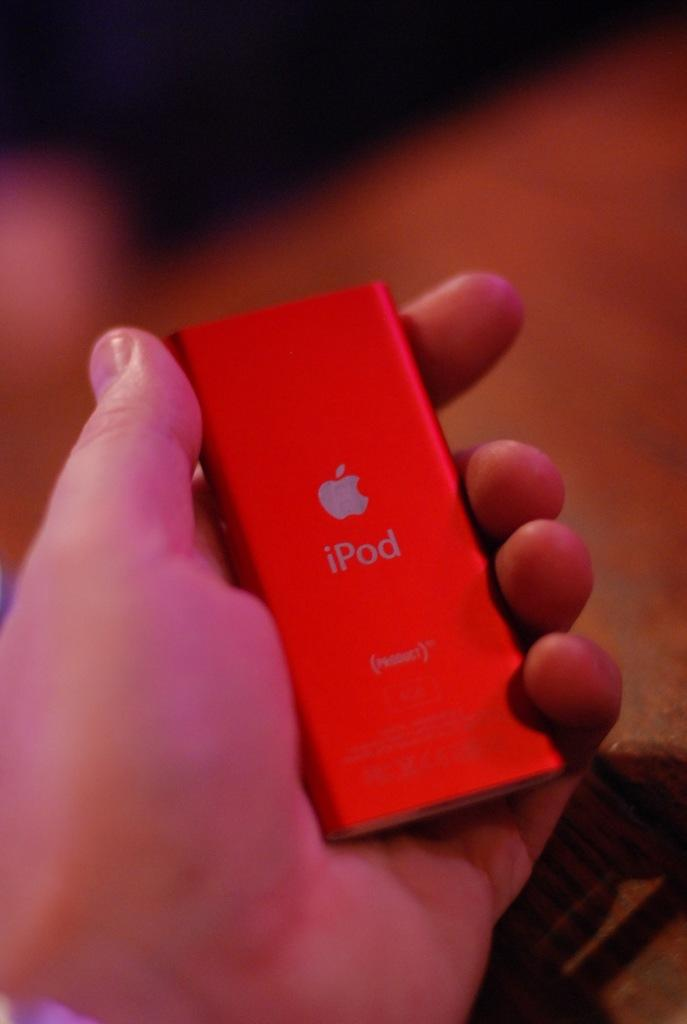Provide a one-sentence caption for the provided image. A hand is holding a red Apple Ipod. 